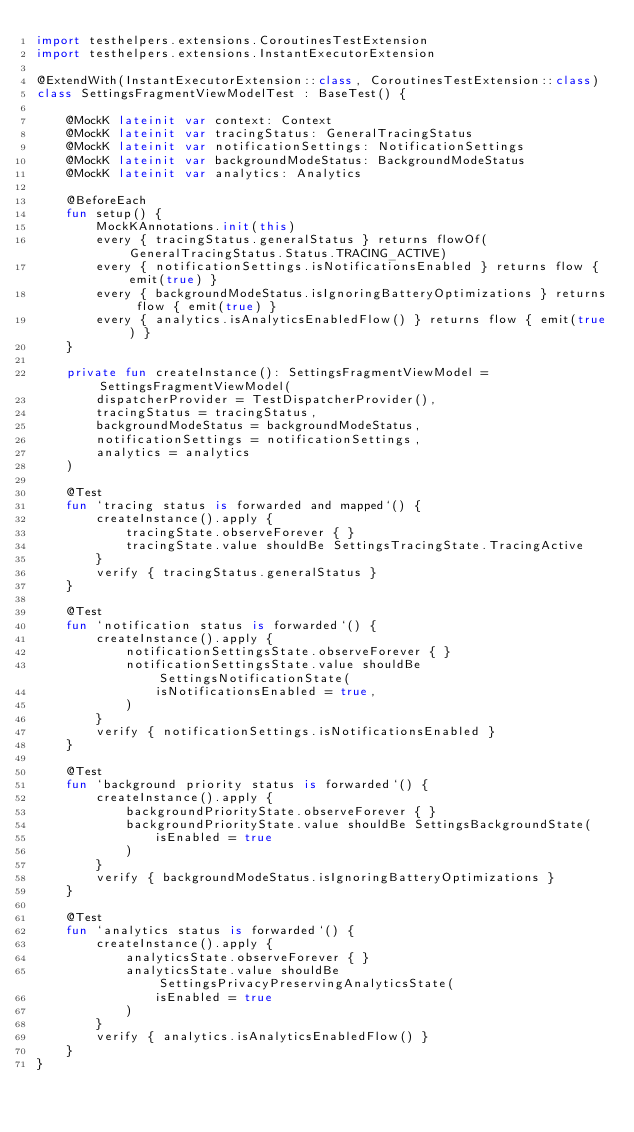<code> <loc_0><loc_0><loc_500><loc_500><_Kotlin_>import testhelpers.extensions.CoroutinesTestExtension
import testhelpers.extensions.InstantExecutorExtension

@ExtendWith(InstantExecutorExtension::class, CoroutinesTestExtension::class)
class SettingsFragmentViewModelTest : BaseTest() {

    @MockK lateinit var context: Context
    @MockK lateinit var tracingStatus: GeneralTracingStatus
    @MockK lateinit var notificationSettings: NotificationSettings
    @MockK lateinit var backgroundModeStatus: BackgroundModeStatus
    @MockK lateinit var analytics: Analytics

    @BeforeEach
    fun setup() {
        MockKAnnotations.init(this)
        every { tracingStatus.generalStatus } returns flowOf(GeneralTracingStatus.Status.TRACING_ACTIVE)
        every { notificationSettings.isNotificationsEnabled } returns flow { emit(true) }
        every { backgroundModeStatus.isIgnoringBatteryOptimizations } returns flow { emit(true) }
        every { analytics.isAnalyticsEnabledFlow() } returns flow { emit(true) }
    }

    private fun createInstance(): SettingsFragmentViewModel = SettingsFragmentViewModel(
        dispatcherProvider = TestDispatcherProvider(),
        tracingStatus = tracingStatus,
        backgroundModeStatus = backgroundModeStatus,
        notificationSettings = notificationSettings,
        analytics = analytics
    )

    @Test
    fun `tracing status is forwarded and mapped`() {
        createInstance().apply {
            tracingState.observeForever { }
            tracingState.value shouldBe SettingsTracingState.TracingActive
        }
        verify { tracingStatus.generalStatus }
    }

    @Test
    fun `notification status is forwarded`() {
        createInstance().apply {
            notificationSettingsState.observeForever { }
            notificationSettingsState.value shouldBe SettingsNotificationState(
                isNotificationsEnabled = true,
            )
        }
        verify { notificationSettings.isNotificationsEnabled }
    }

    @Test
    fun `background priority status is forwarded`() {
        createInstance().apply {
            backgroundPriorityState.observeForever { }
            backgroundPriorityState.value shouldBe SettingsBackgroundState(
                isEnabled = true
            )
        }
        verify { backgroundModeStatus.isIgnoringBatteryOptimizations }
    }

    @Test
    fun `analytics status is forwarded`() {
        createInstance().apply {
            analyticsState.observeForever { }
            analyticsState.value shouldBe SettingsPrivacyPreservingAnalyticsState(
                isEnabled = true
            )
        }
        verify { analytics.isAnalyticsEnabledFlow() }
    }
}
</code> 